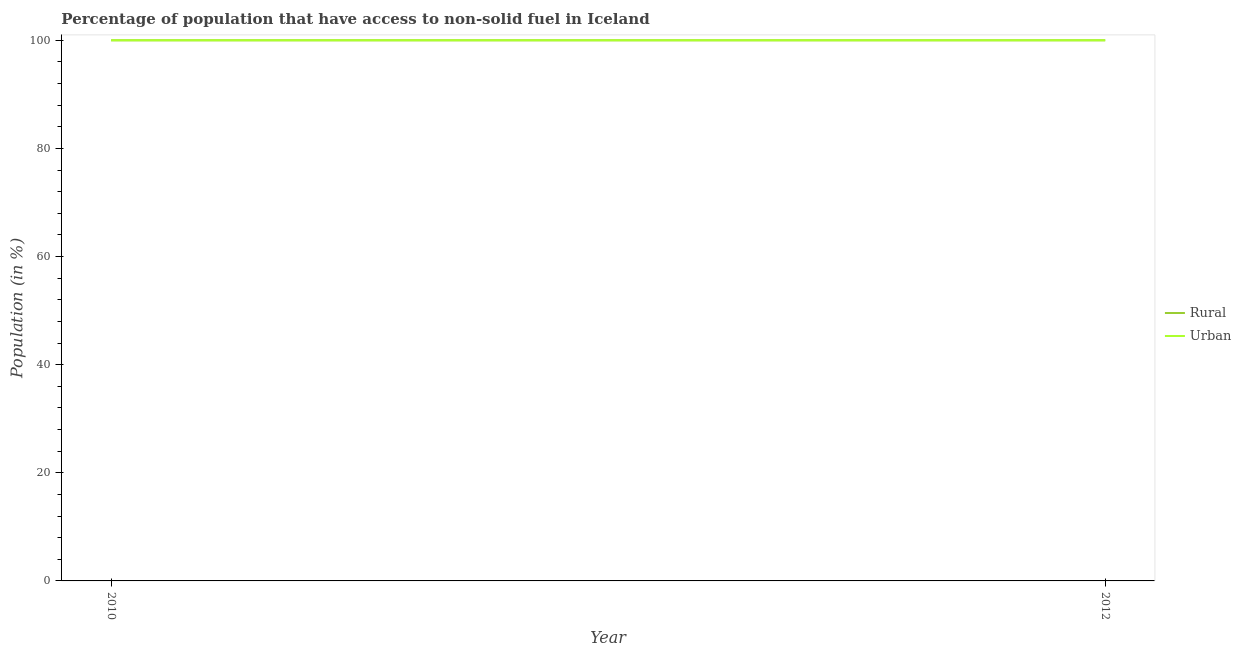How many different coloured lines are there?
Ensure brevity in your answer.  2. Does the line corresponding to urban population intersect with the line corresponding to rural population?
Give a very brief answer. Yes. Is the number of lines equal to the number of legend labels?
Keep it short and to the point. Yes. What is the rural population in 2010?
Your answer should be very brief. 100. Across all years, what is the maximum urban population?
Provide a short and direct response. 100. Across all years, what is the minimum rural population?
Your answer should be very brief. 100. In which year was the rural population maximum?
Provide a succinct answer. 2010. What is the total urban population in the graph?
Offer a terse response. 200. What is the difference between the rural population in 2010 and that in 2012?
Your response must be concise. 0. What is the difference between the rural population in 2012 and the urban population in 2010?
Offer a very short reply. 0. What is the average urban population per year?
Keep it short and to the point. 100. In the year 2012, what is the difference between the rural population and urban population?
Your response must be concise. 0. Is the urban population in 2010 less than that in 2012?
Keep it short and to the point. No. In how many years, is the urban population greater than the average urban population taken over all years?
Make the answer very short. 0. Does the rural population monotonically increase over the years?
Keep it short and to the point. No. Is the rural population strictly greater than the urban population over the years?
Provide a short and direct response. No. How many lines are there?
Offer a terse response. 2. Are the values on the major ticks of Y-axis written in scientific E-notation?
Your response must be concise. No. Does the graph contain any zero values?
Ensure brevity in your answer.  No. How are the legend labels stacked?
Your response must be concise. Vertical. What is the title of the graph?
Offer a terse response. Percentage of population that have access to non-solid fuel in Iceland. Does "Resident workers" appear as one of the legend labels in the graph?
Keep it short and to the point. No. What is the label or title of the X-axis?
Offer a terse response. Year. What is the Population (in %) of Rural in 2010?
Your answer should be compact. 100. What is the Population (in %) of Rural in 2012?
Offer a terse response. 100. What is the Population (in %) of Urban in 2012?
Give a very brief answer. 100. Across all years, what is the maximum Population (in %) of Urban?
Provide a short and direct response. 100. Across all years, what is the minimum Population (in %) in Rural?
Provide a short and direct response. 100. Across all years, what is the minimum Population (in %) in Urban?
Your answer should be very brief. 100. What is the total Population (in %) of Rural in the graph?
Your response must be concise. 200. What is the total Population (in %) of Urban in the graph?
Give a very brief answer. 200. What is the difference between the Population (in %) of Rural in 2010 and that in 2012?
Offer a terse response. 0. What is the difference between the Population (in %) of Urban in 2010 and that in 2012?
Your answer should be very brief. 0. What is the average Population (in %) of Urban per year?
Ensure brevity in your answer.  100. What is the ratio of the Population (in %) in Rural in 2010 to that in 2012?
Your response must be concise. 1. What is the difference between the highest and the second highest Population (in %) in Urban?
Give a very brief answer. 0. What is the difference between the highest and the lowest Population (in %) in Rural?
Provide a succinct answer. 0. What is the difference between the highest and the lowest Population (in %) of Urban?
Give a very brief answer. 0. 